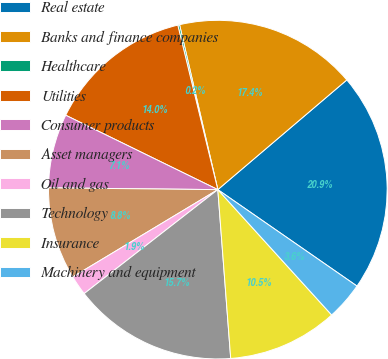<chart> <loc_0><loc_0><loc_500><loc_500><pie_chart><fcel>Real estate<fcel>Banks and finance companies<fcel>Healthcare<fcel>Utilities<fcel>Consumer products<fcel>Asset managers<fcel>Oil and gas<fcel>Technology<fcel>Insurance<fcel>Machinery and equipment<nl><fcel>20.86%<fcel>17.41%<fcel>0.17%<fcel>13.96%<fcel>7.07%<fcel>8.79%<fcel>1.9%<fcel>15.69%<fcel>10.52%<fcel>3.62%<nl></chart> 